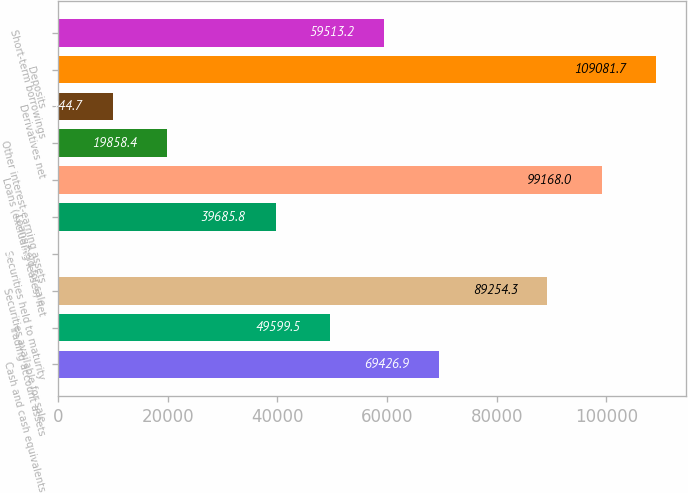<chart> <loc_0><loc_0><loc_500><loc_500><bar_chart><fcel>Cash and cash equivalents<fcel>Trading account assets<fcel>Securities available for sale<fcel>Securities held to maturity<fcel>Loans held for sale<fcel>Loans (excluding leases) net<fcel>Other interest-earning assets<fcel>Derivatives net<fcel>Deposits<fcel>Short-term borrowings<nl><fcel>69426.9<fcel>49599.5<fcel>89254.3<fcel>31<fcel>39685.8<fcel>99168<fcel>19858.4<fcel>9944.7<fcel>109082<fcel>59513.2<nl></chart> 